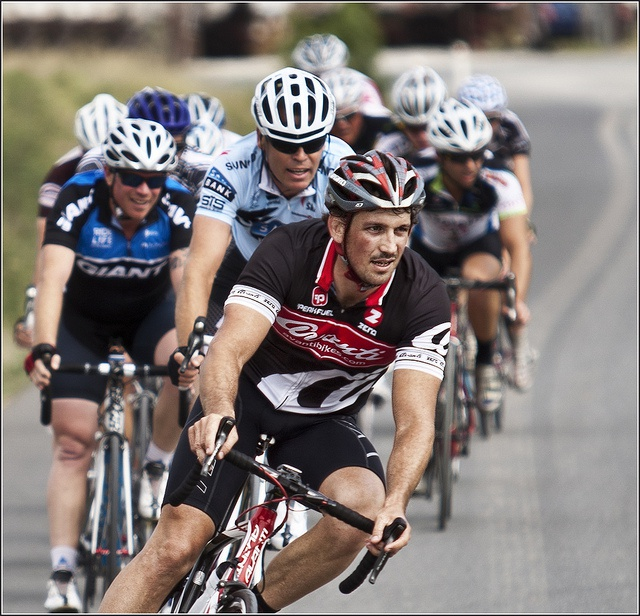Describe the objects in this image and their specific colors. I can see people in black, tan, lightgray, and darkgray tones, people in black, gray, darkgray, and lightgray tones, people in black, white, tan, and gray tones, people in black, gray, lightgray, and darkgray tones, and bicycle in black, white, gray, and darkgray tones in this image. 